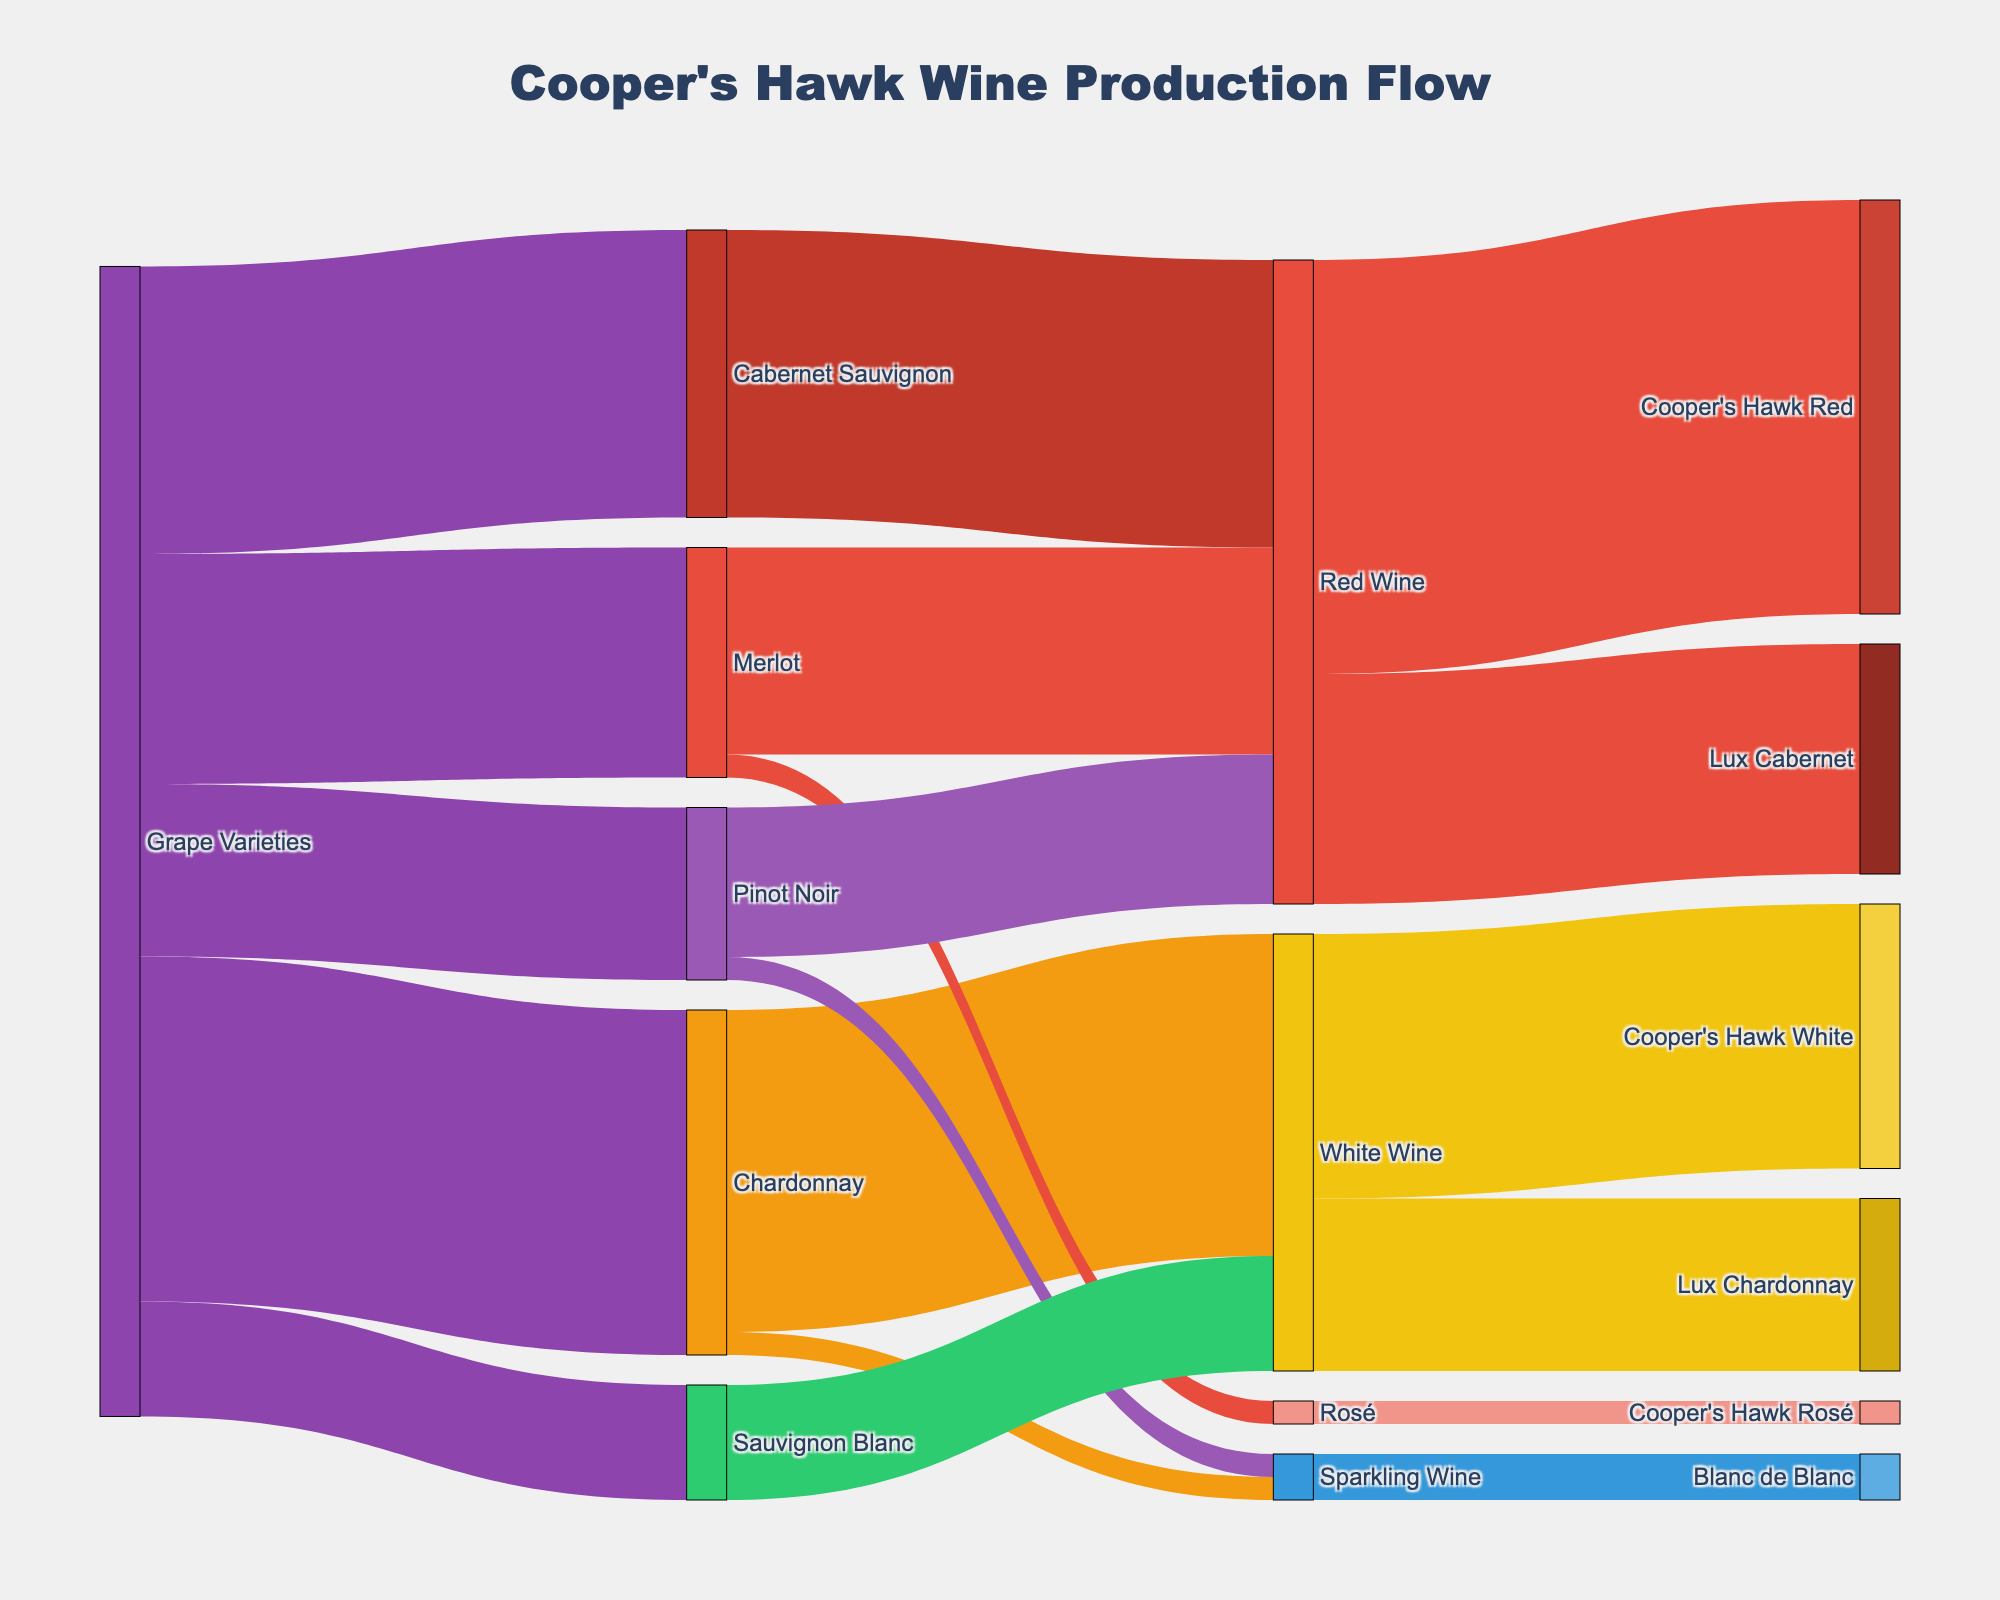What's the title of the Sankey diagram? The title appears at the top of the diagram, usually in a larger font size with specific styling chosen to make it easily noticeable. In this case, the title is designated to describe the overall content of the figure.
Answer: Cooper's Hawk Wine Production Flow How many types of wines are produced from Sauvignon Blanc grapes? Observing the flows from the "Sauvignon Blanc" node, there is only one direct connection leading to another node. This indicates that all wine production from this grape variety culminates in a single type.
Answer: 1 Which grape variety contributes the most to red wine production? Examining the connections from various grape varieties to "Red Wine," the one with the thickest link (representing the highest value) directly towards "Red Wine" determines which grape variety contributes the most.
Answer: Cabernet Sauvignon What's the total production value of wines associated with Merlot grapes? Look at all the connections coming from "Merlot" and sum their values: Red Wine (18) and Rosé (2). So, 18 + 2 results in the total production value.
Answer: 20 Which category of wine has the highest number of sub-categories? Identify each main category (White Wine, Red Wine, Sparkling Wine, Rosé) and count the target connections originating from each one. The one with the highest number of connections will have the most sub-categories.
Answer: Red Wine How many wine categories does Chardonnay contribute to? Trace all the direct target connections from the "Chardonnay" node. Each link leads to a different wine category, and counting these links gives the total number of wine categories Chardonnay contributes to.
Answer: 2 What's the total production value of White Wines? Aggregate the production values associated with "White Wine" and its sub-categories: Lux Chardonnay (15) and Cooper's Hawk White (23). The sum is 15 + 23.
Answer: 38 Which category does not derive directly from "Grape Varieties"? Check the target nodes of "Grape Varieties" and identify which primary wine categories are not directly connected to it. In this diagram, only "Rosé" is not directly originated from "Grape Varieties."
Answer: Rosé Is there any grape variety that contributes to both Red and Sparkling wines? Observe the paths from each grape variety node, checking if any of them have separate connections to both "Red Wine" and "Sparkling Wine" categories. The only grape variety that fits this condition is "Pinot Noir."
Answer: Yes 